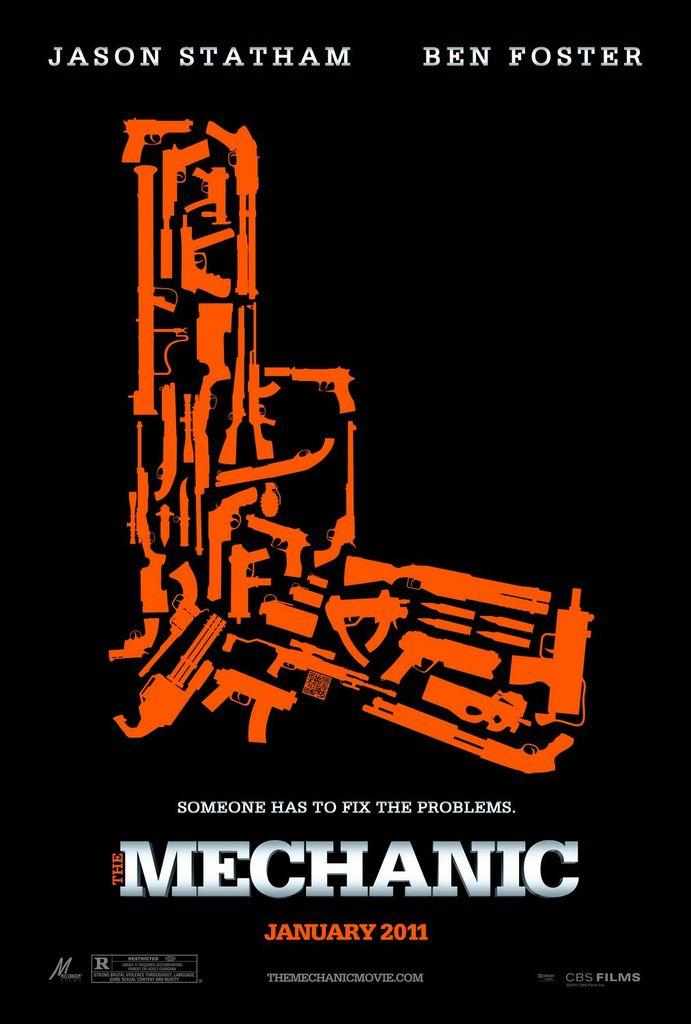<image>
Render a clear and concise summary of the photo. An advertisement for Mechanic shows that it will be coming out in January 2011. 